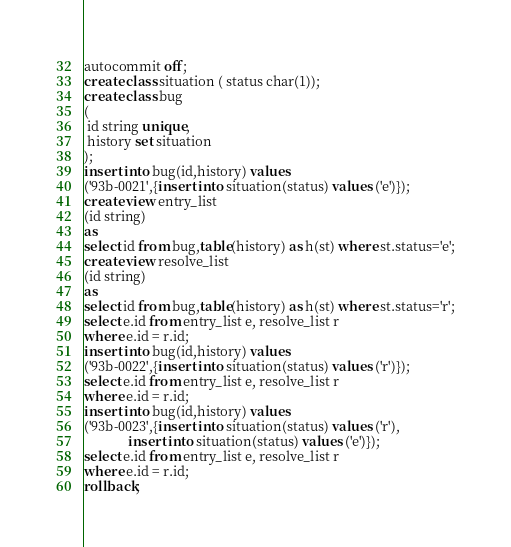<code> <loc_0><loc_0><loc_500><loc_500><_SQL_>autocommit off;
create class situation ( status char(1));
create class bug
(
 id string unique,
 history set situation
);
insert into bug(id,history) values
('93b-0021',{insert into situation(status) values ('e')});
create view entry_list
(id string)
as
select id from bug,table(history) as h(st) where st.status='e';
create view resolve_list
(id string)
as
select id from bug,table(history) as h(st) where st.status='r';
select e.id from entry_list e, resolve_list r
where e.id = r.id;
insert into bug(id,history) values
('93b-0022',{insert into situation(status) values ('r')});
select e.id from entry_list e, resolve_list r
where e.id = r.id;
insert into bug(id,history) values
('93b-0023',{insert into situation(status) values ('r'),
             insert into situation(status) values ('e')});
select e.id from entry_list e, resolve_list r
where e.id = r.id;
rollback;
</code> 